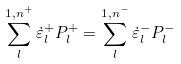<formula> <loc_0><loc_0><loc_500><loc_500>\sum _ { l } ^ { 1 , n ^ { + } } \dot { \varepsilon } _ { l } ^ { + } P _ { l } ^ { + } = \sum _ { l } ^ { 1 , n ^ { - } } \dot { \varepsilon } _ { l } ^ { - } P _ { l } ^ { - }</formula> 